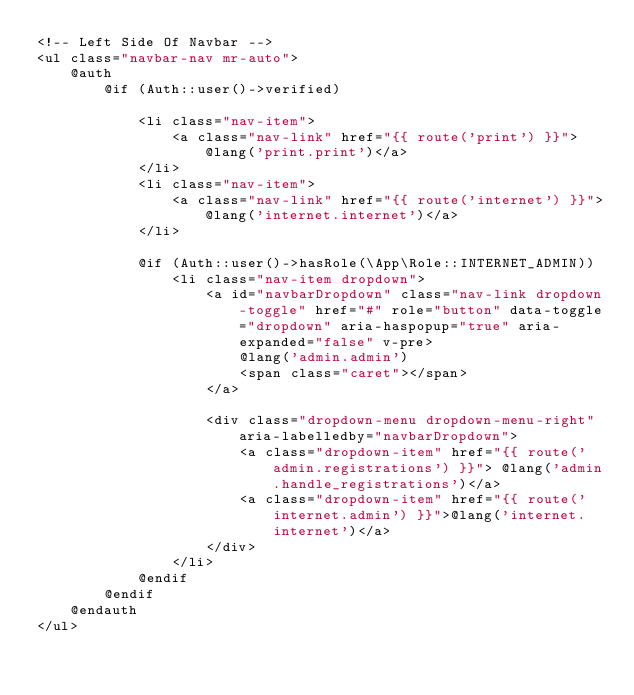Convert code to text. <code><loc_0><loc_0><loc_500><loc_500><_PHP_><!-- Left Side Of Navbar -->
<ul class="navbar-nav mr-auto">
    @auth
        @if (Auth::user()->verified)
        
            <li class="nav-item">
                <a class="nav-link" href="{{ route('print') }}">@lang('print.print')</a>
            </li>
            <li class="nav-item">
                <a class="nav-link" href="{{ route('internet') }}">@lang('internet.internet')</a>
            </li>
            
            @if (Auth::user()->hasRole(\App\Role::INTERNET_ADMIN))
                <li class="nav-item dropdown">
                    <a id="navbarDropdown" class="nav-link dropdown-toggle" href="#" role="button" data-toggle="dropdown" aria-haspopup="true" aria-expanded="false" v-pre>
                        @lang('admin.admin')
                        <span class="caret"></span>
                    </a>

                    <div class="dropdown-menu dropdown-menu-right" aria-labelledby="navbarDropdown">
                        <a class="dropdown-item" href="{{ route('admin.registrations') }}"> @lang('admin.handle_registrations')</a>
                        <a class="dropdown-item" href="{{ route('internet.admin') }}">@lang('internet.internet')</a>
                    </div>
                </li>
            @endif
        @endif
    @endauth
</ul>
</code> 